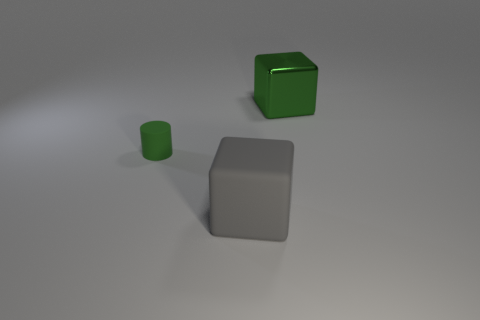What time of day does the lighting in the image suggest? The lighting in the image is neutral and diffused, suggesting an overcast day or a setting with soft artificial light, possibly from a studio. 